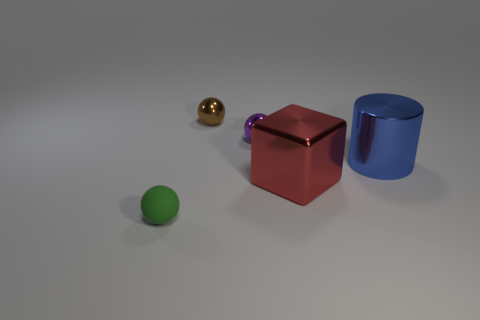Add 2 purple shiny things. How many objects exist? 7 Subtract all tiny brown metallic spheres. How many spheres are left? 2 Subtract all red blocks. How many brown balls are left? 1 Subtract all purple spheres. How many spheres are left? 2 Subtract all cyan cylinders. Subtract all purple balls. How many cylinders are left? 1 Subtract 0 yellow cylinders. How many objects are left? 5 Subtract all cubes. How many objects are left? 4 Subtract all large red cubes. Subtract all large red shiny things. How many objects are left? 3 Add 4 red objects. How many red objects are left? 5 Add 5 blue shiny objects. How many blue shiny objects exist? 6 